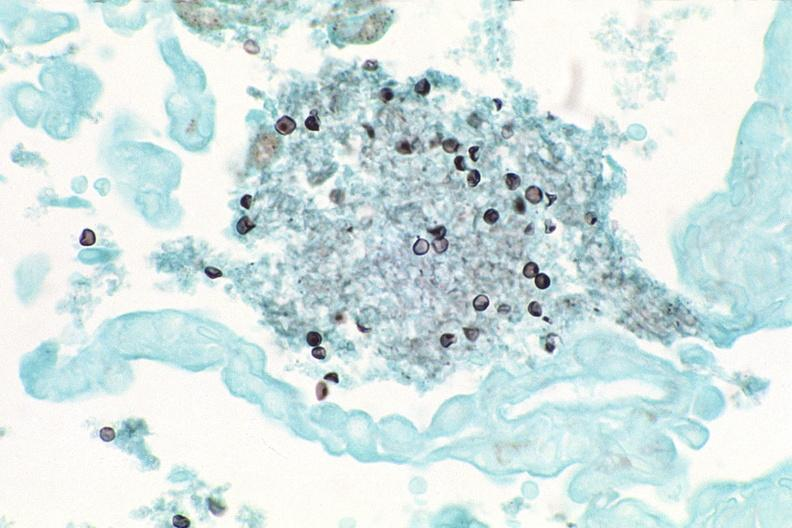what is present?
Answer the question using a single word or phrase. Respiratory 